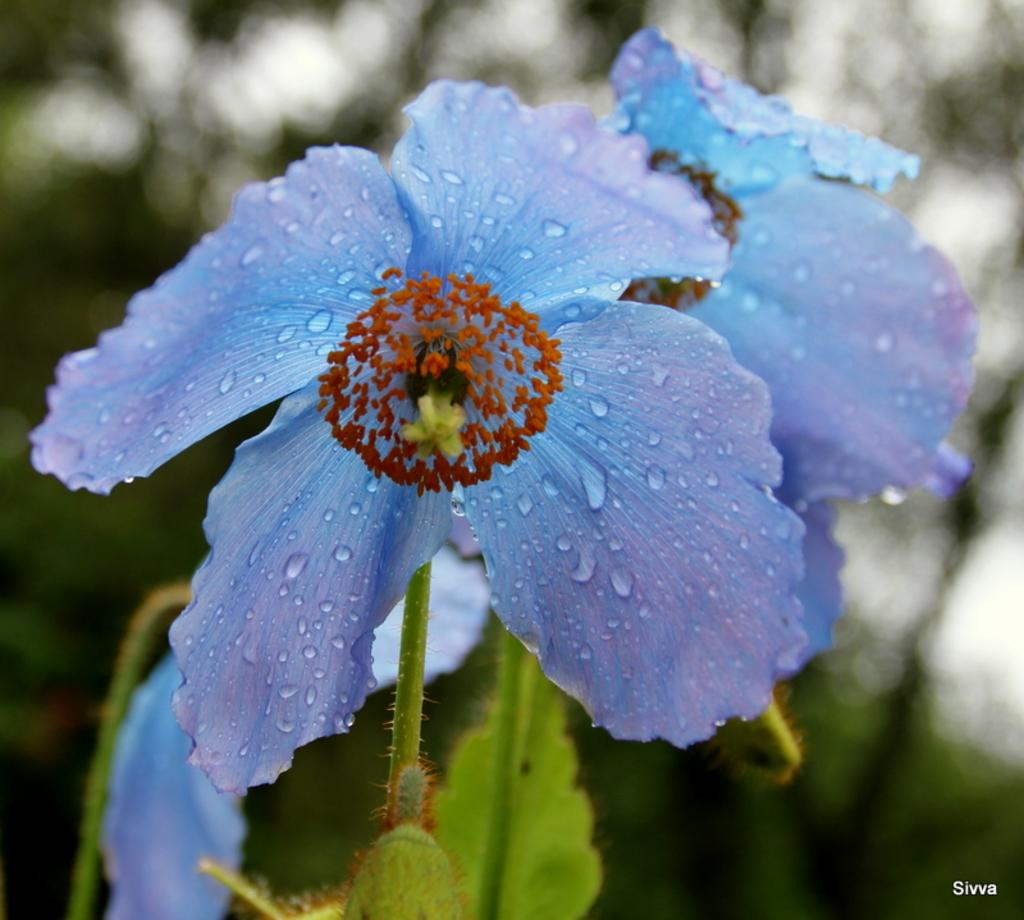How many flowers can be seen in the image? There are two flowers in the image. Where are the flowers located? The flowers are on plants. What can be observed about the background of the flowers? The background of the flowers is blurred. What type of pancake is being sold at the store in the image? There is no store or pancake present in the image; it features two flowers on plants with a blurred background. 